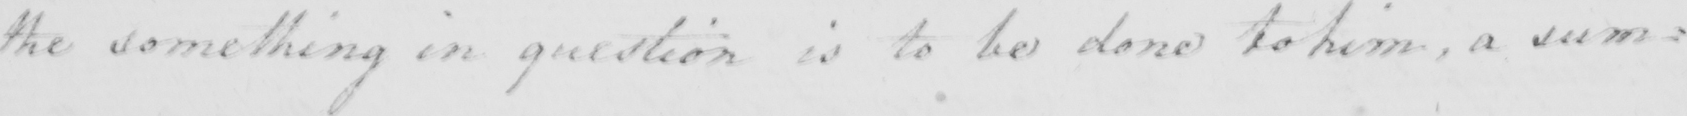What does this handwritten line say? the something in question is to be done to him , a sum : 